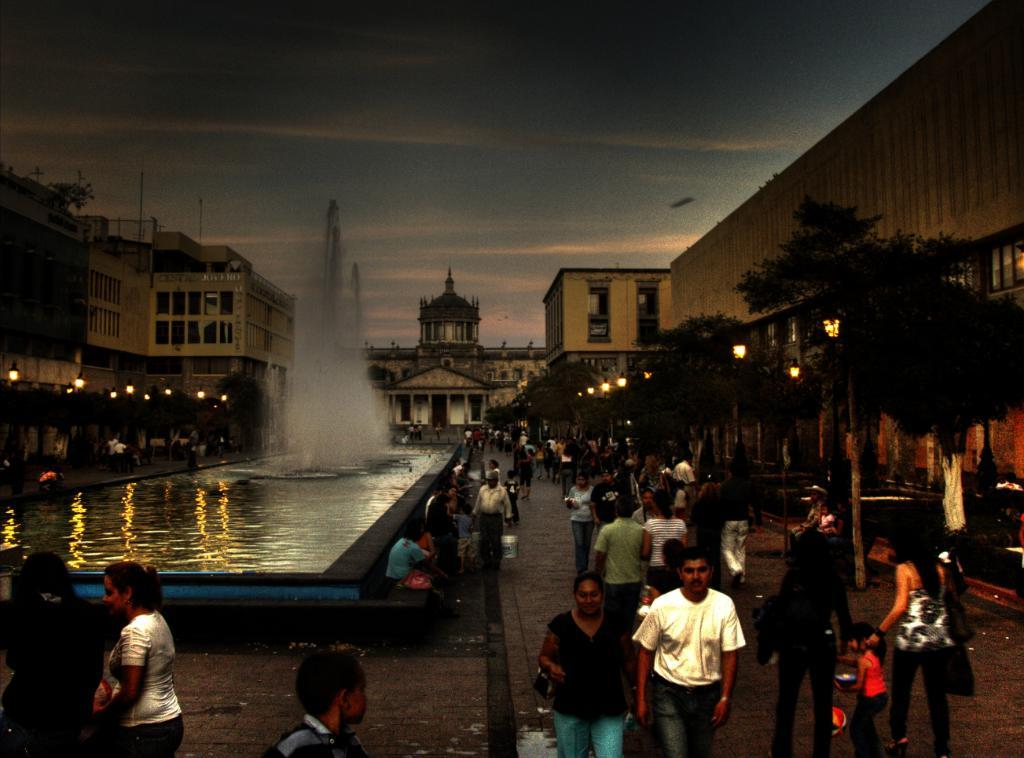Who or what can be seen in the image? There are people in the image. What type of natural elements are present in the image? There are trees in the image. What is a notable feature in the image? There is a fountain in the image. What can be seen illuminating the scene? There are lights in the image. What type of man-made structures are visible? There are buildings in the image. What shape is the hole in the image? There is no hole present in the image. What type of cheese is being used to create the lights in the image? There is no cheese present in the image; the lights are not made of cheese. 